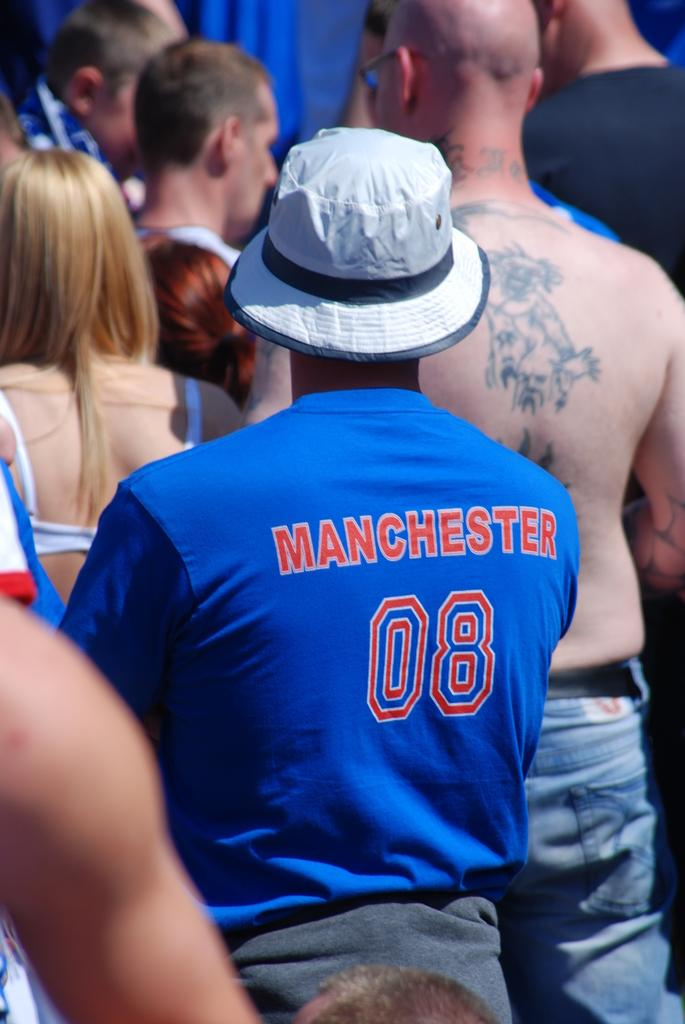<image>
Share a concise interpretation of the image provided. a person that is wearing a Manchester shirt on their back 